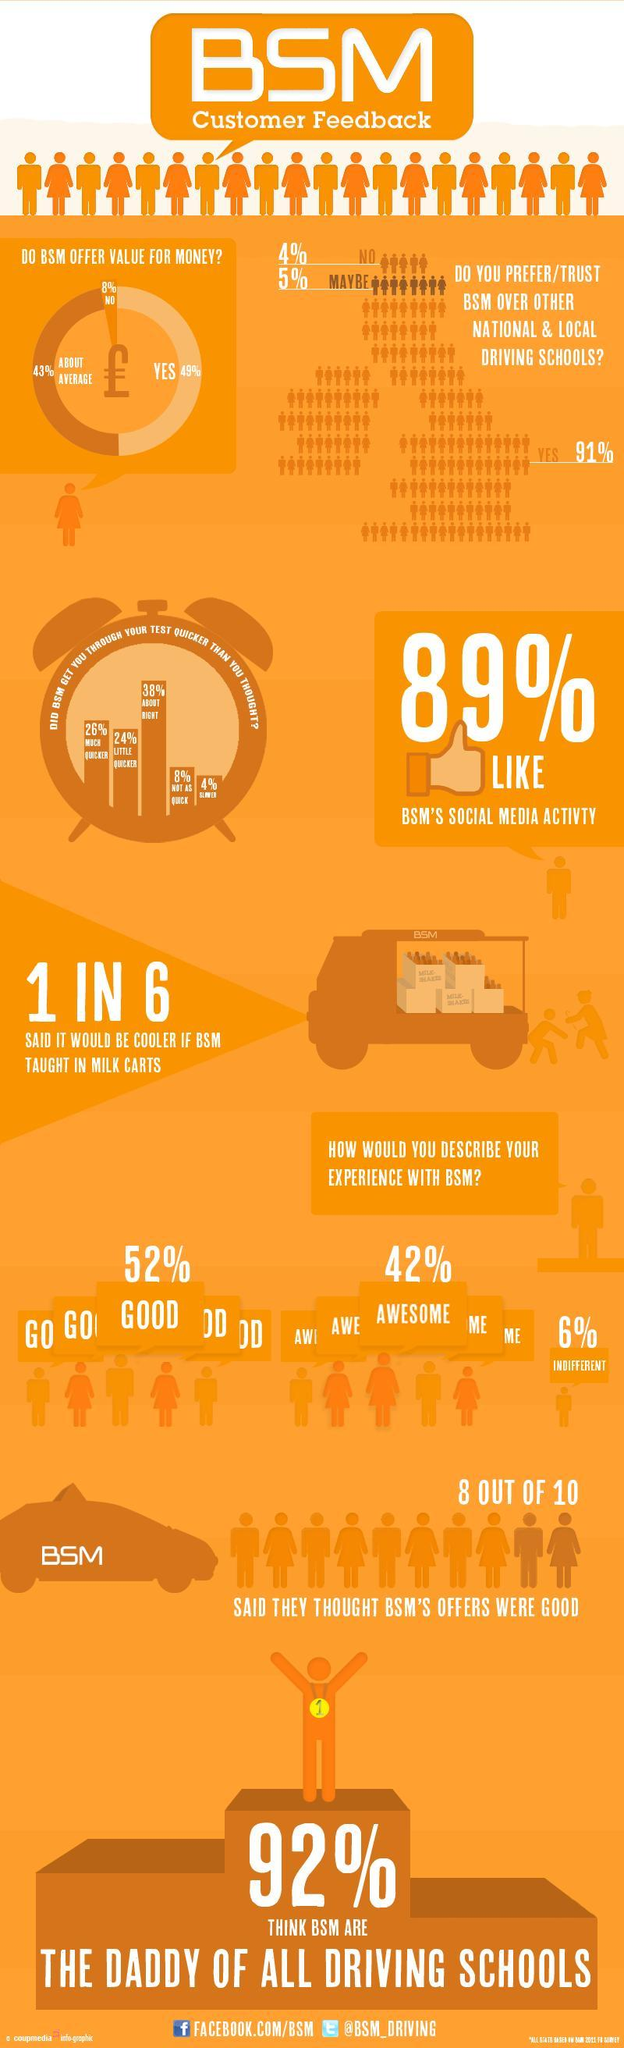What was the percentage of people described their experience with BSM was good, 52%, 42% or 6%?
Answer the question with a short phrase. 52% What is the total percentage of people though that BSM helped them through the driving test little and much quicker? 50% 